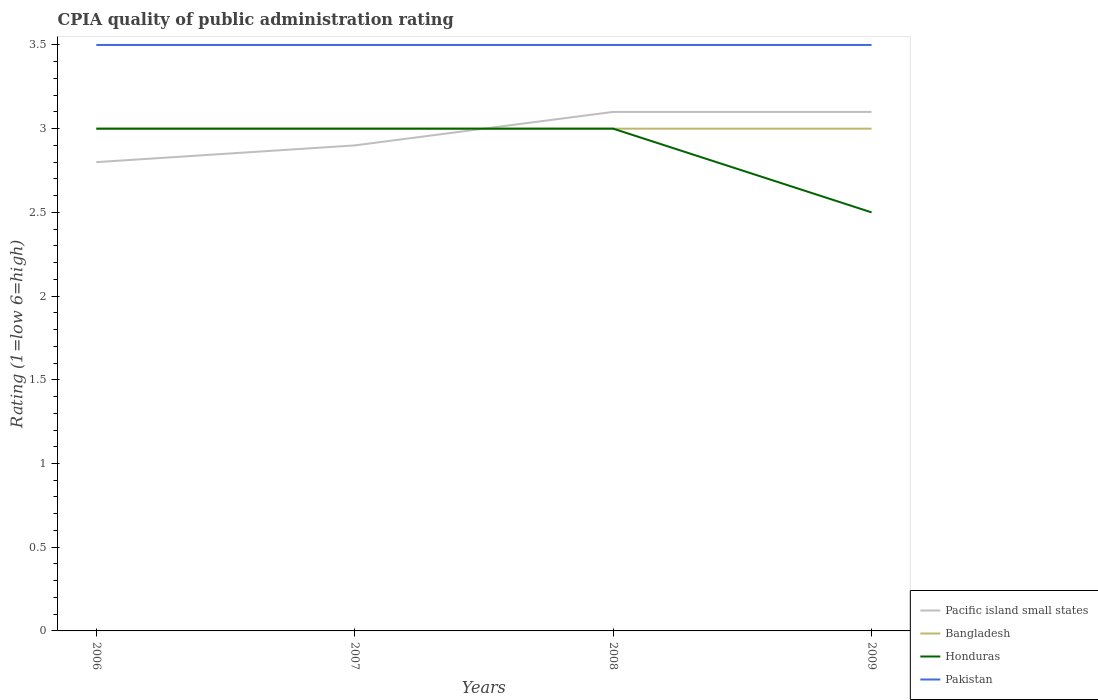Does the line corresponding to Pacific island small states intersect with the line corresponding to Bangladesh?
Your response must be concise. Yes. Is the number of lines equal to the number of legend labels?
Offer a terse response. Yes. Across all years, what is the maximum CPIA rating in Honduras?
Your answer should be compact. 2.5. In which year was the CPIA rating in Pakistan maximum?
Ensure brevity in your answer.  2006. What is the difference between the highest and the second highest CPIA rating in Pakistan?
Ensure brevity in your answer.  0. Is the CPIA rating in Pacific island small states strictly greater than the CPIA rating in Pakistan over the years?
Your response must be concise. Yes. How many years are there in the graph?
Keep it short and to the point. 4. Does the graph contain any zero values?
Your answer should be compact. No. Where does the legend appear in the graph?
Provide a short and direct response. Bottom right. How many legend labels are there?
Your answer should be compact. 4. What is the title of the graph?
Your response must be concise. CPIA quality of public administration rating. What is the label or title of the X-axis?
Keep it short and to the point. Years. What is the Rating (1=low 6=high) in Bangladesh in 2007?
Your response must be concise. 3. What is the Rating (1=low 6=high) of Bangladesh in 2008?
Your response must be concise. 3. What is the Rating (1=low 6=high) in Honduras in 2008?
Offer a terse response. 3. What is the Rating (1=low 6=high) in Pakistan in 2008?
Offer a terse response. 3.5. What is the Rating (1=low 6=high) in Pacific island small states in 2009?
Your answer should be compact. 3.1. What is the Rating (1=low 6=high) of Bangladesh in 2009?
Your answer should be compact. 3. What is the Rating (1=low 6=high) in Honduras in 2009?
Ensure brevity in your answer.  2.5. What is the Rating (1=low 6=high) in Pakistan in 2009?
Make the answer very short. 3.5. Across all years, what is the maximum Rating (1=low 6=high) in Bangladesh?
Give a very brief answer. 3. Across all years, what is the minimum Rating (1=low 6=high) of Pacific island small states?
Make the answer very short. 2.8. Across all years, what is the minimum Rating (1=low 6=high) of Honduras?
Offer a very short reply. 2.5. Across all years, what is the minimum Rating (1=low 6=high) of Pakistan?
Your answer should be compact. 3.5. What is the total Rating (1=low 6=high) in Honduras in the graph?
Give a very brief answer. 11.5. What is the difference between the Rating (1=low 6=high) of Bangladesh in 2006 and that in 2007?
Your response must be concise. 0. What is the difference between the Rating (1=low 6=high) of Honduras in 2006 and that in 2007?
Ensure brevity in your answer.  0. What is the difference between the Rating (1=low 6=high) of Honduras in 2006 and that in 2008?
Keep it short and to the point. 0. What is the difference between the Rating (1=low 6=high) of Pakistan in 2006 and that in 2008?
Offer a terse response. 0. What is the difference between the Rating (1=low 6=high) in Pacific island small states in 2006 and that in 2009?
Your answer should be very brief. -0.3. What is the difference between the Rating (1=low 6=high) of Pakistan in 2006 and that in 2009?
Offer a terse response. 0. What is the difference between the Rating (1=low 6=high) in Pacific island small states in 2007 and that in 2008?
Offer a terse response. -0.2. What is the difference between the Rating (1=low 6=high) of Bangladesh in 2007 and that in 2008?
Your response must be concise. 0. What is the difference between the Rating (1=low 6=high) in Honduras in 2007 and that in 2008?
Offer a terse response. 0. What is the difference between the Rating (1=low 6=high) of Pakistan in 2007 and that in 2008?
Offer a terse response. 0. What is the difference between the Rating (1=low 6=high) of Honduras in 2007 and that in 2009?
Offer a very short reply. 0.5. What is the difference between the Rating (1=low 6=high) in Pakistan in 2007 and that in 2009?
Keep it short and to the point. 0. What is the difference between the Rating (1=low 6=high) of Honduras in 2008 and that in 2009?
Provide a succinct answer. 0.5. What is the difference between the Rating (1=low 6=high) of Pakistan in 2008 and that in 2009?
Provide a succinct answer. 0. What is the difference between the Rating (1=low 6=high) in Pacific island small states in 2006 and the Rating (1=low 6=high) in Bangladesh in 2007?
Keep it short and to the point. -0.2. What is the difference between the Rating (1=low 6=high) in Pacific island small states in 2006 and the Rating (1=low 6=high) in Honduras in 2007?
Offer a very short reply. -0.2. What is the difference between the Rating (1=low 6=high) in Pacific island small states in 2006 and the Rating (1=low 6=high) in Pakistan in 2007?
Your answer should be compact. -0.7. What is the difference between the Rating (1=low 6=high) of Bangladesh in 2006 and the Rating (1=low 6=high) of Pakistan in 2007?
Your answer should be compact. -0.5. What is the difference between the Rating (1=low 6=high) in Honduras in 2006 and the Rating (1=low 6=high) in Pakistan in 2007?
Offer a terse response. -0.5. What is the difference between the Rating (1=low 6=high) in Pacific island small states in 2006 and the Rating (1=low 6=high) in Bangladesh in 2008?
Your answer should be compact. -0.2. What is the difference between the Rating (1=low 6=high) in Pacific island small states in 2006 and the Rating (1=low 6=high) in Honduras in 2008?
Your answer should be compact. -0.2. What is the difference between the Rating (1=low 6=high) of Pacific island small states in 2006 and the Rating (1=low 6=high) of Pakistan in 2008?
Your answer should be very brief. -0.7. What is the difference between the Rating (1=low 6=high) in Bangladesh in 2006 and the Rating (1=low 6=high) in Honduras in 2008?
Your response must be concise. 0. What is the difference between the Rating (1=low 6=high) of Pacific island small states in 2006 and the Rating (1=low 6=high) of Bangladesh in 2009?
Give a very brief answer. -0.2. What is the difference between the Rating (1=low 6=high) of Pacific island small states in 2006 and the Rating (1=low 6=high) of Honduras in 2009?
Your response must be concise. 0.3. What is the difference between the Rating (1=low 6=high) of Pacific island small states in 2006 and the Rating (1=low 6=high) of Pakistan in 2009?
Your response must be concise. -0.7. What is the difference between the Rating (1=low 6=high) of Bangladesh in 2006 and the Rating (1=low 6=high) of Honduras in 2009?
Offer a very short reply. 0.5. What is the difference between the Rating (1=low 6=high) of Bangladesh in 2006 and the Rating (1=low 6=high) of Pakistan in 2009?
Ensure brevity in your answer.  -0.5. What is the difference between the Rating (1=low 6=high) in Honduras in 2006 and the Rating (1=low 6=high) in Pakistan in 2009?
Offer a terse response. -0.5. What is the difference between the Rating (1=low 6=high) of Bangladesh in 2007 and the Rating (1=low 6=high) of Pakistan in 2008?
Keep it short and to the point. -0.5. What is the difference between the Rating (1=low 6=high) in Pacific island small states in 2007 and the Rating (1=low 6=high) in Bangladesh in 2009?
Your answer should be very brief. -0.1. What is the difference between the Rating (1=low 6=high) of Pacific island small states in 2007 and the Rating (1=low 6=high) of Pakistan in 2009?
Your answer should be very brief. -0.6. What is the difference between the Rating (1=low 6=high) in Bangladesh in 2007 and the Rating (1=low 6=high) in Pakistan in 2009?
Keep it short and to the point. -0.5. What is the difference between the Rating (1=low 6=high) of Honduras in 2007 and the Rating (1=low 6=high) of Pakistan in 2009?
Your response must be concise. -0.5. What is the difference between the Rating (1=low 6=high) in Pacific island small states in 2008 and the Rating (1=low 6=high) in Bangladesh in 2009?
Keep it short and to the point. 0.1. What is the difference between the Rating (1=low 6=high) in Pacific island small states in 2008 and the Rating (1=low 6=high) in Honduras in 2009?
Your answer should be compact. 0.6. What is the difference between the Rating (1=low 6=high) of Bangladesh in 2008 and the Rating (1=low 6=high) of Honduras in 2009?
Keep it short and to the point. 0.5. What is the difference between the Rating (1=low 6=high) in Bangladesh in 2008 and the Rating (1=low 6=high) in Pakistan in 2009?
Your answer should be very brief. -0.5. What is the average Rating (1=low 6=high) of Pacific island small states per year?
Make the answer very short. 2.98. What is the average Rating (1=low 6=high) of Bangladesh per year?
Ensure brevity in your answer.  3. What is the average Rating (1=low 6=high) of Honduras per year?
Your answer should be compact. 2.88. What is the average Rating (1=low 6=high) of Pakistan per year?
Your answer should be very brief. 3.5. In the year 2006, what is the difference between the Rating (1=low 6=high) of Pacific island small states and Rating (1=low 6=high) of Pakistan?
Give a very brief answer. -0.7. In the year 2006, what is the difference between the Rating (1=low 6=high) in Bangladesh and Rating (1=low 6=high) in Pakistan?
Keep it short and to the point. -0.5. In the year 2007, what is the difference between the Rating (1=low 6=high) of Pacific island small states and Rating (1=low 6=high) of Honduras?
Your response must be concise. -0.1. In the year 2007, what is the difference between the Rating (1=low 6=high) of Bangladesh and Rating (1=low 6=high) of Honduras?
Offer a very short reply. 0. In the year 2008, what is the difference between the Rating (1=low 6=high) of Pacific island small states and Rating (1=low 6=high) of Pakistan?
Your answer should be very brief. -0.4. In the year 2008, what is the difference between the Rating (1=low 6=high) in Bangladesh and Rating (1=low 6=high) in Pakistan?
Keep it short and to the point. -0.5. In the year 2008, what is the difference between the Rating (1=low 6=high) of Honduras and Rating (1=low 6=high) of Pakistan?
Keep it short and to the point. -0.5. In the year 2009, what is the difference between the Rating (1=low 6=high) of Pacific island small states and Rating (1=low 6=high) of Pakistan?
Ensure brevity in your answer.  -0.4. In the year 2009, what is the difference between the Rating (1=low 6=high) of Honduras and Rating (1=low 6=high) of Pakistan?
Give a very brief answer. -1. What is the ratio of the Rating (1=low 6=high) in Pacific island small states in 2006 to that in 2007?
Ensure brevity in your answer.  0.97. What is the ratio of the Rating (1=low 6=high) of Honduras in 2006 to that in 2007?
Your answer should be compact. 1. What is the ratio of the Rating (1=low 6=high) in Pacific island small states in 2006 to that in 2008?
Your response must be concise. 0.9. What is the ratio of the Rating (1=low 6=high) in Bangladesh in 2006 to that in 2008?
Provide a succinct answer. 1. What is the ratio of the Rating (1=low 6=high) in Honduras in 2006 to that in 2008?
Offer a very short reply. 1. What is the ratio of the Rating (1=low 6=high) in Pakistan in 2006 to that in 2008?
Your answer should be very brief. 1. What is the ratio of the Rating (1=low 6=high) of Pacific island small states in 2006 to that in 2009?
Make the answer very short. 0.9. What is the ratio of the Rating (1=low 6=high) in Bangladesh in 2006 to that in 2009?
Give a very brief answer. 1. What is the ratio of the Rating (1=low 6=high) in Pakistan in 2006 to that in 2009?
Offer a terse response. 1. What is the ratio of the Rating (1=low 6=high) of Pacific island small states in 2007 to that in 2008?
Keep it short and to the point. 0.94. What is the ratio of the Rating (1=low 6=high) of Honduras in 2007 to that in 2008?
Ensure brevity in your answer.  1. What is the ratio of the Rating (1=low 6=high) of Pakistan in 2007 to that in 2008?
Offer a very short reply. 1. What is the ratio of the Rating (1=low 6=high) in Pacific island small states in 2007 to that in 2009?
Your response must be concise. 0.94. What is the ratio of the Rating (1=low 6=high) in Honduras in 2007 to that in 2009?
Offer a terse response. 1.2. What is the ratio of the Rating (1=low 6=high) in Pakistan in 2007 to that in 2009?
Provide a succinct answer. 1. What is the ratio of the Rating (1=low 6=high) of Pacific island small states in 2008 to that in 2009?
Make the answer very short. 1. What is the ratio of the Rating (1=low 6=high) in Bangladesh in 2008 to that in 2009?
Ensure brevity in your answer.  1. What is the ratio of the Rating (1=low 6=high) in Honduras in 2008 to that in 2009?
Ensure brevity in your answer.  1.2. What is the difference between the highest and the second highest Rating (1=low 6=high) in Pacific island small states?
Provide a short and direct response. 0. What is the difference between the highest and the second highest Rating (1=low 6=high) in Bangladesh?
Give a very brief answer. 0. What is the difference between the highest and the lowest Rating (1=low 6=high) in Bangladesh?
Provide a short and direct response. 0. What is the difference between the highest and the lowest Rating (1=low 6=high) in Honduras?
Your answer should be very brief. 0.5. 